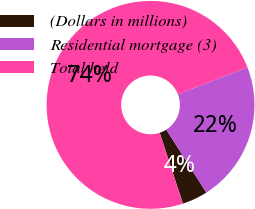Convert chart. <chart><loc_0><loc_0><loc_500><loc_500><pie_chart><fcel>(Dollars in millions)<fcel>Residential mortgage (3)<fcel>Total held<nl><fcel>3.97%<fcel>21.88%<fcel>74.15%<nl></chart> 